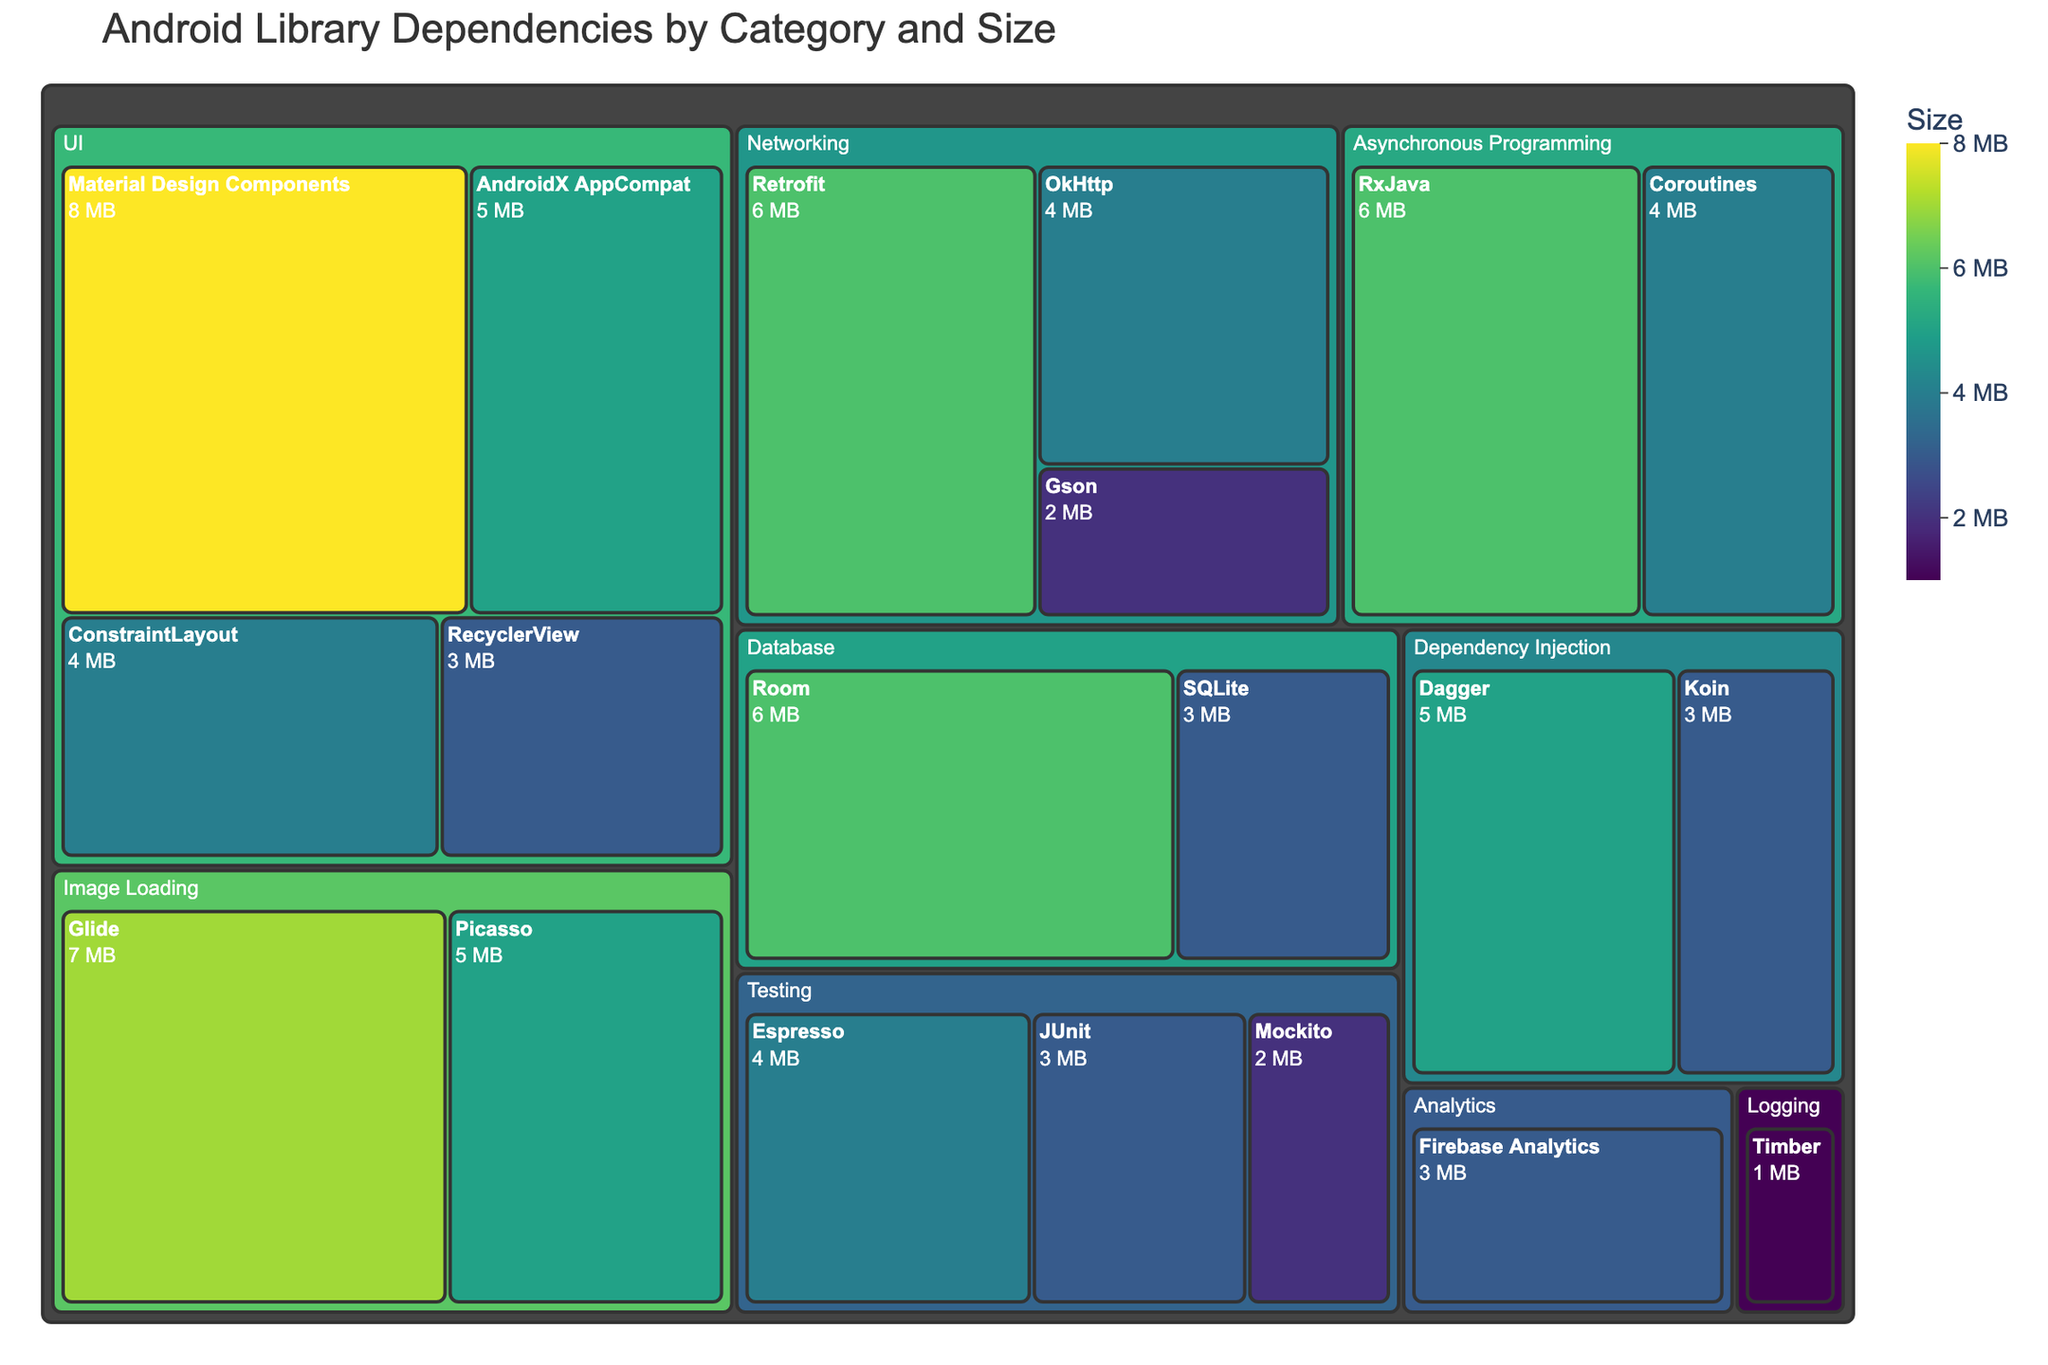What's the title of the treemap? The title of a treemap is usually displayed prominently at the top or in a noticeable position so that viewers can quickly understand what the chart is about. By looking at the top of the figure, the title "Android Library Dependencies by Category and Size" is clearly shown.
Answer: Android Library Dependencies by Category and Size Which category has the highest total size? To determine the category with the highest total size, sum the sizes of all libraries within each category and compare the totals. Upon examining the treemap, we can see that the UI category has the highest total size, adding up (5 + 8 + 4 + 3) to 20 MB.
Answer: UI How many libraries are there in the Networking category? In the treemap, libraries within the Networking category are grouped together. By counting the libraries shown in this group, we can tell there are three Networking libraries: Retrofit, OkHttp, and Gson.
Answer: 3 Which library has the smallest size? The library with the smallest size can be found by identifying the smallest colored rectangle in the treemap. From the visual, Timber in the Logging category has the smallest size, which is 1 MB.
Answer: Timber Is JUnit larger or smaller in size compared to Espresso? To compare the sizes of JUnit and Espresso, look at their respective rectangles in the treemap. JUnit is 3 MB while Espresso is 4 MB, indicating JUnit is smaller.
Answer: Smaller What's the combined size of the Material Design Components and Glide libraries? To find the combined size, sum up the sizes of both libraries. Material Design Components is 8 MB and Glide is 7 MB. Adding these together results in 15 MB.
Answer: 15 MB Are there more libraries in Database or Testing categories? To determine which category has more libraries, count the number of libraries listed under each category. Database has two libraries (Room and SQLite), and Testing also has three libraries (JUnit, Espresso, Mockito).
Answer: Testing Which library in the UI category has the largest size? Examine the libraries within the UI category and compare their sizes. Material Design Components has the largest size within this category at 8 MB.
Answer: Material Design Components What is the average size of libraries in the Dependency Injection category? First, sum the sizes of the libraries in the Dependency Injection category, then divide by the number of libraries. Dagger is 5 MB and Koin is 3 MB. (5 + 3) / 2 = 4 MB.
Answer: 4 MB What is the range of sizes for libraries in the Asynchronous Programming category? To determine the range, find the difference between the largest and smallest sizes within the category. Coroutines is 4 MB and RxJava is 6 MB. The range is 6 - 4 = 2 MB.
Answer: 2 MB 